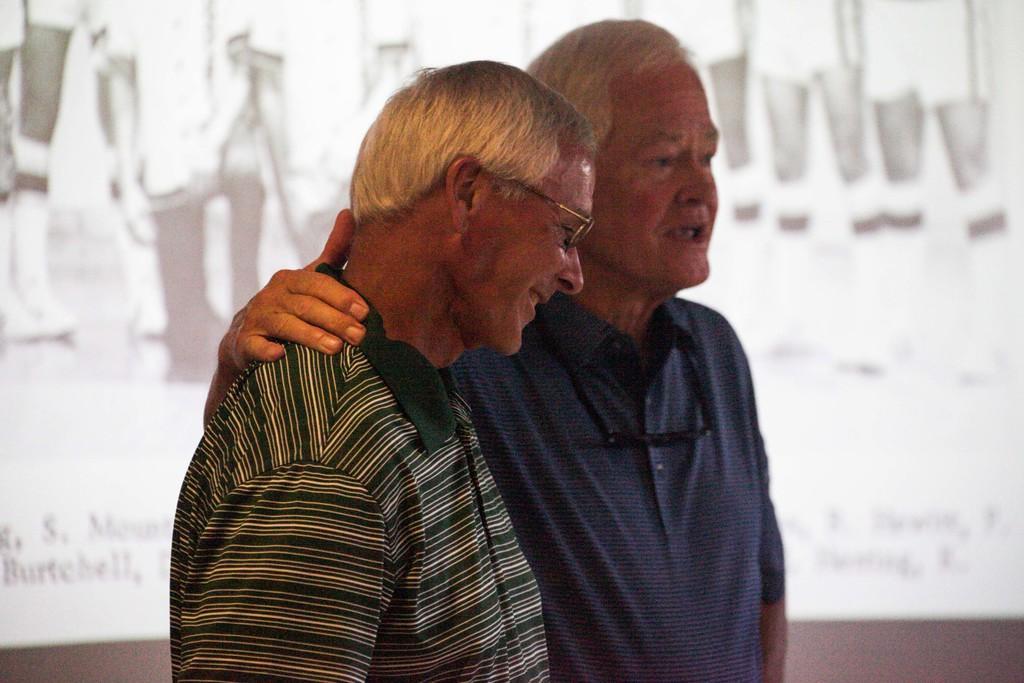Describe this image in one or two sentences. In the middle of the picture, the man in green T-shirt who is wearing spectacles is standing. He is smiling. Beside him, the man in the blue shirt is standing. I think he is talking. Behind them, we see a white board or a projector screen which is displaying something on it. 